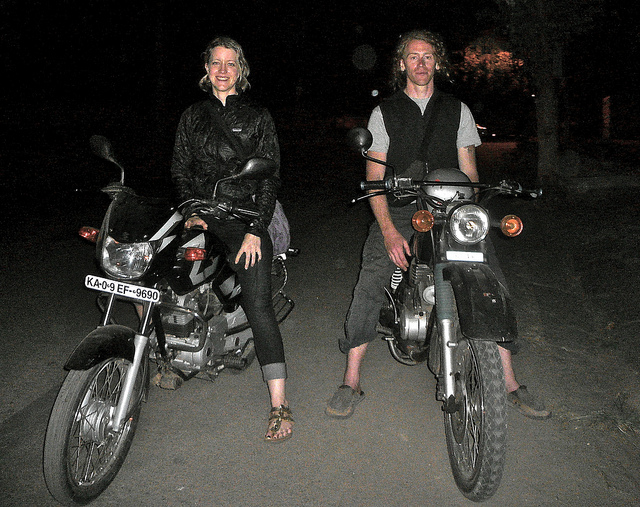How many people are in the picture? 2 